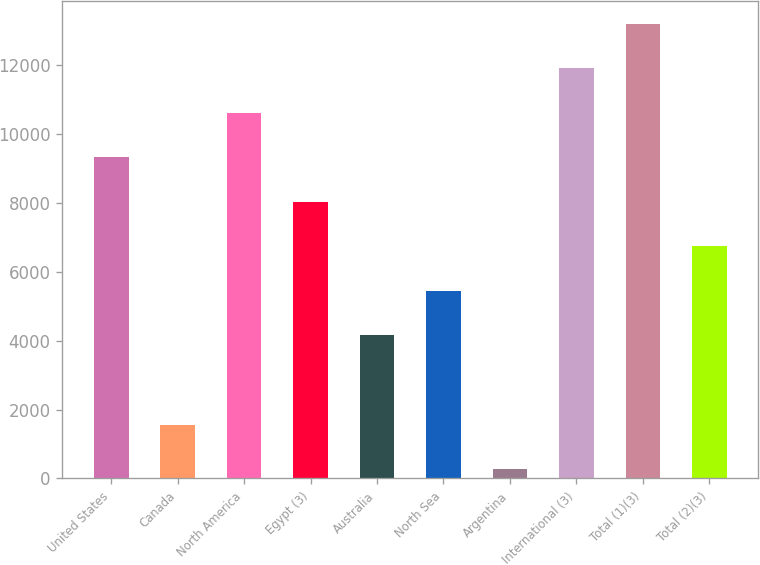Convert chart to OTSL. <chart><loc_0><loc_0><loc_500><loc_500><bar_chart><fcel>United States<fcel>Canada<fcel>North America<fcel>Egypt (3)<fcel>Australia<fcel>North Sea<fcel>Argentina<fcel>International (3)<fcel>Total (1)(3)<fcel>Total (2)(3)<nl><fcel>9328.3<fcel>1564.9<fcel>10622.2<fcel>8034.4<fcel>4152.7<fcel>5446.6<fcel>271<fcel>11916.1<fcel>13210<fcel>6740.5<nl></chart> 